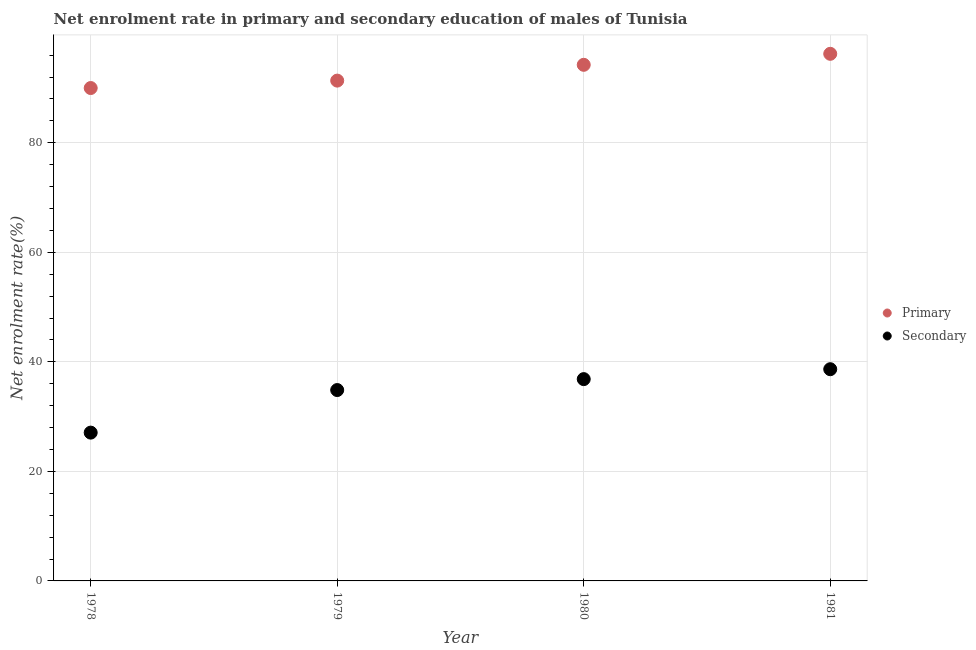How many different coloured dotlines are there?
Offer a very short reply. 2. What is the enrollment rate in primary education in 1978?
Offer a very short reply. 89.99. Across all years, what is the maximum enrollment rate in primary education?
Your response must be concise. 96.24. Across all years, what is the minimum enrollment rate in secondary education?
Your response must be concise. 27.08. In which year was the enrollment rate in secondary education maximum?
Ensure brevity in your answer.  1981. In which year was the enrollment rate in primary education minimum?
Provide a short and direct response. 1978. What is the total enrollment rate in secondary education in the graph?
Ensure brevity in your answer.  137.43. What is the difference between the enrollment rate in primary education in 1980 and that in 1981?
Your answer should be compact. -2.01. What is the difference between the enrollment rate in secondary education in 1979 and the enrollment rate in primary education in 1978?
Your answer should be compact. -55.14. What is the average enrollment rate in primary education per year?
Your answer should be compact. 92.95. In the year 1980, what is the difference between the enrollment rate in secondary education and enrollment rate in primary education?
Your response must be concise. -57.39. What is the ratio of the enrollment rate in primary education in 1979 to that in 1980?
Keep it short and to the point. 0.97. Is the enrollment rate in secondary education in 1979 less than that in 1981?
Your answer should be very brief. Yes. Is the difference between the enrollment rate in secondary education in 1979 and 1981 greater than the difference between the enrollment rate in primary education in 1979 and 1981?
Your response must be concise. Yes. What is the difference between the highest and the second highest enrollment rate in secondary education?
Make the answer very short. 1.81. What is the difference between the highest and the lowest enrollment rate in secondary education?
Ensure brevity in your answer.  11.58. Does the enrollment rate in secondary education monotonically increase over the years?
Offer a very short reply. Yes. What is the difference between two consecutive major ticks on the Y-axis?
Offer a very short reply. 20. Does the graph contain any zero values?
Provide a short and direct response. No. Does the graph contain grids?
Keep it short and to the point. Yes. How many legend labels are there?
Your response must be concise. 2. What is the title of the graph?
Ensure brevity in your answer.  Net enrolment rate in primary and secondary education of males of Tunisia. Does "Under five" appear as one of the legend labels in the graph?
Offer a very short reply. No. What is the label or title of the Y-axis?
Provide a short and direct response. Net enrolment rate(%). What is the Net enrolment rate(%) in Primary in 1978?
Offer a very short reply. 89.99. What is the Net enrolment rate(%) of Secondary in 1978?
Make the answer very short. 27.08. What is the Net enrolment rate(%) of Primary in 1979?
Give a very brief answer. 91.35. What is the Net enrolment rate(%) in Secondary in 1979?
Ensure brevity in your answer.  34.85. What is the Net enrolment rate(%) of Primary in 1980?
Your answer should be very brief. 94.23. What is the Net enrolment rate(%) of Secondary in 1980?
Offer a very short reply. 36.85. What is the Net enrolment rate(%) in Primary in 1981?
Give a very brief answer. 96.24. What is the Net enrolment rate(%) of Secondary in 1981?
Provide a short and direct response. 38.66. Across all years, what is the maximum Net enrolment rate(%) in Primary?
Offer a very short reply. 96.24. Across all years, what is the maximum Net enrolment rate(%) of Secondary?
Your answer should be compact. 38.66. Across all years, what is the minimum Net enrolment rate(%) of Primary?
Ensure brevity in your answer.  89.99. Across all years, what is the minimum Net enrolment rate(%) of Secondary?
Give a very brief answer. 27.08. What is the total Net enrolment rate(%) in Primary in the graph?
Your answer should be very brief. 371.81. What is the total Net enrolment rate(%) of Secondary in the graph?
Offer a terse response. 137.43. What is the difference between the Net enrolment rate(%) of Primary in 1978 and that in 1979?
Your answer should be compact. -1.36. What is the difference between the Net enrolment rate(%) of Secondary in 1978 and that in 1979?
Provide a succinct answer. -7.77. What is the difference between the Net enrolment rate(%) in Primary in 1978 and that in 1980?
Ensure brevity in your answer.  -4.24. What is the difference between the Net enrolment rate(%) of Secondary in 1978 and that in 1980?
Offer a terse response. -9.77. What is the difference between the Net enrolment rate(%) of Primary in 1978 and that in 1981?
Offer a very short reply. -6.25. What is the difference between the Net enrolment rate(%) of Secondary in 1978 and that in 1981?
Your answer should be very brief. -11.58. What is the difference between the Net enrolment rate(%) of Primary in 1979 and that in 1980?
Give a very brief answer. -2.88. What is the difference between the Net enrolment rate(%) of Secondary in 1979 and that in 1980?
Keep it short and to the point. -2. What is the difference between the Net enrolment rate(%) in Primary in 1979 and that in 1981?
Your answer should be very brief. -4.89. What is the difference between the Net enrolment rate(%) of Secondary in 1979 and that in 1981?
Keep it short and to the point. -3.81. What is the difference between the Net enrolment rate(%) of Primary in 1980 and that in 1981?
Your answer should be very brief. -2.01. What is the difference between the Net enrolment rate(%) of Secondary in 1980 and that in 1981?
Your response must be concise. -1.81. What is the difference between the Net enrolment rate(%) of Primary in 1978 and the Net enrolment rate(%) of Secondary in 1979?
Provide a succinct answer. 55.14. What is the difference between the Net enrolment rate(%) in Primary in 1978 and the Net enrolment rate(%) in Secondary in 1980?
Offer a very short reply. 53.15. What is the difference between the Net enrolment rate(%) of Primary in 1978 and the Net enrolment rate(%) of Secondary in 1981?
Provide a succinct answer. 51.34. What is the difference between the Net enrolment rate(%) in Primary in 1979 and the Net enrolment rate(%) in Secondary in 1980?
Your answer should be compact. 54.5. What is the difference between the Net enrolment rate(%) in Primary in 1979 and the Net enrolment rate(%) in Secondary in 1981?
Ensure brevity in your answer.  52.69. What is the difference between the Net enrolment rate(%) in Primary in 1980 and the Net enrolment rate(%) in Secondary in 1981?
Provide a succinct answer. 55.58. What is the average Net enrolment rate(%) of Primary per year?
Your response must be concise. 92.95. What is the average Net enrolment rate(%) in Secondary per year?
Provide a succinct answer. 34.36. In the year 1978, what is the difference between the Net enrolment rate(%) in Primary and Net enrolment rate(%) in Secondary?
Offer a very short reply. 62.92. In the year 1979, what is the difference between the Net enrolment rate(%) in Primary and Net enrolment rate(%) in Secondary?
Offer a terse response. 56.5. In the year 1980, what is the difference between the Net enrolment rate(%) of Primary and Net enrolment rate(%) of Secondary?
Your answer should be compact. 57.39. In the year 1981, what is the difference between the Net enrolment rate(%) of Primary and Net enrolment rate(%) of Secondary?
Keep it short and to the point. 57.58. What is the ratio of the Net enrolment rate(%) of Primary in 1978 to that in 1979?
Your answer should be compact. 0.99. What is the ratio of the Net enrolment rate(%) in Secondary in 1978 to that in 1979?
Give a very brief answer. 0.78. What is the ratio of the Net enrolment rate(%) in Primary in 1978 to that in 1980?
Ensure brevity in your answer.  0.95. What is the ratio of the Net enrolment rate(%) in Secondary in 1978 to that in 1980?
Offer a very short reply. 0.73. What is the ratio of the Net enrolment rate(%) in Primary in 1978 to that in 1981?
Ensure brevity in your answer.  0.94. What is the ratio of the Net enrolment rate(%) in Secondary in 1978 to that in 1981?
Provide a succinct answer. 0.7. What is the ratio of the Net enrolment rate(%) in Primary in 1979 to that in 1980?
Provide a succinct answer. 0.97. What is the ratio of the Net enrolment rate(%) of Secondary in 1979 to that in 1980?
Offer a very short reply. 0.95. What is the ratio of the Net enrolment rate(%) of Primary in 1979 to that in 1981?
Provide a short and direct response. 0.95. What is the ratio of the Net enrolment rate(%) in Secondary in 1979 to that in 1981?
Your answer should be very brief. 0.9. What is the ratio of the Net enrolment rate(%) in Primary in 1980 to that in 1981?
Offer a terse response. 0.98. What is the ratio of the Net enrolment rate(%) of Secondary in 1980 to that in 1981?
Your answer should be compact. 0.95. What is the difference between the highest and the second highest Net enrolment rate(%) in Primary?
Your answer should be compact. 2.01. What is the difference between the highest and the second highest Net enrolment rate(%) in Secondary?
Ensure brevity in your answer.  1.81. What is the difference between the highest and the lowest Net enrolment rate(%) of Primary?
Make the answer very short. 6.25. What is the difference between the highest and the lowest Net enrolment rate(%) of Secondary?
Offer a very short reply. 11.58. 